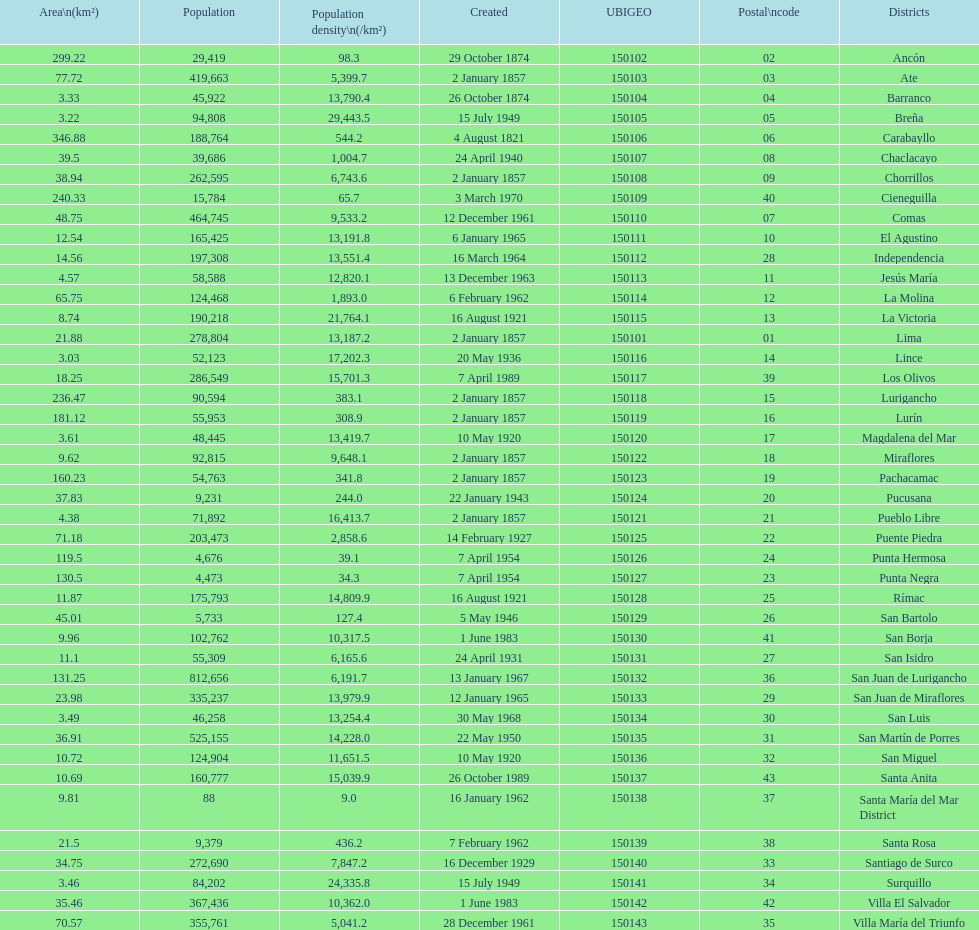How many districts are there in this city? 43. Could you help me parse every detail presented in this table? {'header': ['Area\\n(km²)', 'Population', 'Population density\\n(/km²)', 'Created', 'UBIGEO', 'Postal\\ncode', 'Districts'], 'rows': [['299.22', '29,419', '98.3', '29 October 1874', '150102', '02', 'Ancón'], ['77.72', '419,663', '5,399.7', '2 January 1857', '150103', '03', 'Ate'], ['3.33', '45,922', '13,790.4', '26 October 1874', '150104', '04', 'Barranco'], ['3.22', '94,808', '29,443.5', '15 July 1949', '150105', '05', 'Breña'], ['346.88', '188,764', '544.2', '4 August 1821', '150106', '06', 'Carabayllo'], ['39.5', '39,686', '1,004.7', '24 April 1940', '150107', '08', 'Chaclacayo'], ['38.94', '262,595', '6,743.6', '2 January 1857', '150108', '09', 'Chorrillos'], ['240.33', '15,784', '65.7', '3 March 1970', '150109', '40', 'Cieneguilla'], ['48.75', '464,745', '9,533.2', '12 December 1961', '150110', '07', 'Comas'], ['12.54', '165,425', '13,191.8', '6 January 1965', '150111', '10', 'El Agustino'], ['14.56', '197,308', '13,551.4', '16 March 1964', '150112', '28', 'Independencia'], ['4.57', '58,588', '12,820.1', '13 December 1963', '150113', '11', 'Jesús María'], ['65.75', '124,468', '1,893.0', '6 February 1962', '150114', '12', 'La Molina'], ['8.74', '190,218', '21,764.1', '16 August 1921', '150115', '13', 'La Victoria'], ['21.88', '278,804', '13,187.2', '2 January 1857', '150101', '01', 'Lima'], ['3.03', '52,123', '17,202.3', '20 May 1936', '150116', '14', 'Lince'], ['18.25', '286,549', '15,701.3', '7 April 1989', '150117', '39', 'Los Olivos'], ['236.47', '90,594', '383.1', '2 January 1857', '150118', '15', 'Lurigancho'], ['181.12', '55,953', '308.9', '2 January 1857', '150119', '16', 'Lurín'], ['3.61', '48,445', '13,419.7', '10 May 1920', '150120', '17', 'Magdalena del Mar'], ['9.62', '92,815', '9,648.1', '2 January 1857', '150122', '18', 'Miraflores'], ['160.23', '54,763', '341.8', '2 January 1857', '150123', '19', 'Pachacamac'], ['37.83', '9,231', '244.0', '22 January 1943', '150124', '20', 'Pucusana'], ['4.38', '71,892', '16,413.7', '2 January 1857', '150121', '21', 'Pueblo Libre'], ['71.18', '203,473', '2,858.6', '14 February 1927', '150125', '22', 'Puente Piedra'], ['119.5', '4,676', '39.1', '7 April 1954', '150126', '24', 'Punta Hermosa'], ['130.5', '4,473', '34.3', '7 April 1954', '150127', '23', 'Punta Negra'], ['11.87', '175,793', '14,809.9', '16 August 1921', '150128', '25', 'Rímac'], ['45.01', '5,733', '127.4', '5 May 1946', '150129', '26', 'San Bartolo'], ['9.96', '102,762', '10,317.5', '1 June 1983', '150130', '41', 'San Borja'], ['11.1', '55,309', '6,165.6', '24 April 1931', '150131', '27', 'San Isidro'], ['131.25', '812,656', '6,191.7', '13 January 1967', '150132', '36', 'San Juan de Lurigancho'], ['23.98', '335,237', '13,979.9', '12 January 1965', '150133', '29', 'San Juan de Miraflores'], ['3.49', '46,258', '13,254.4', '30 May 1968', '150134', '30', 'San Luis'], ['36.91', '525,155', '14,228.0', '22 May 1950', '150135', '31', 'San Martín de Porres'], ['10.72', '124,904', '11,651.5', '10 May 1920', '150136', '32', 'San Miguel'], ['10.69', '160,777', '15,039.9', '26 October 1989', '150137', '43', 'Santa Anita'], ['9.81', '88', '9.0', '16 January 1962', '150138', '37', 'Santa María del Mar District'], ['21.5', '9,379', '436.2', '7 February 1962', '150139', '38', 'Santa Rosa'], ['34.75', '272,690', '7,847.2', '16 December 1929', '150140', '33', 'Santiago de Surco'], ['3.46', '84,202', '24,335.8', '15 July 1949', '150141', '34', 'Surquillo'], ['35.46', '367,436', '10,362.0', '1 June 1983', '150142', '42', 'Villa El Salvador'], ['70.57', '355,761', '5,041.2', '28 December 1961', '150143', '35', 'Villa María del Triunfo']]} 